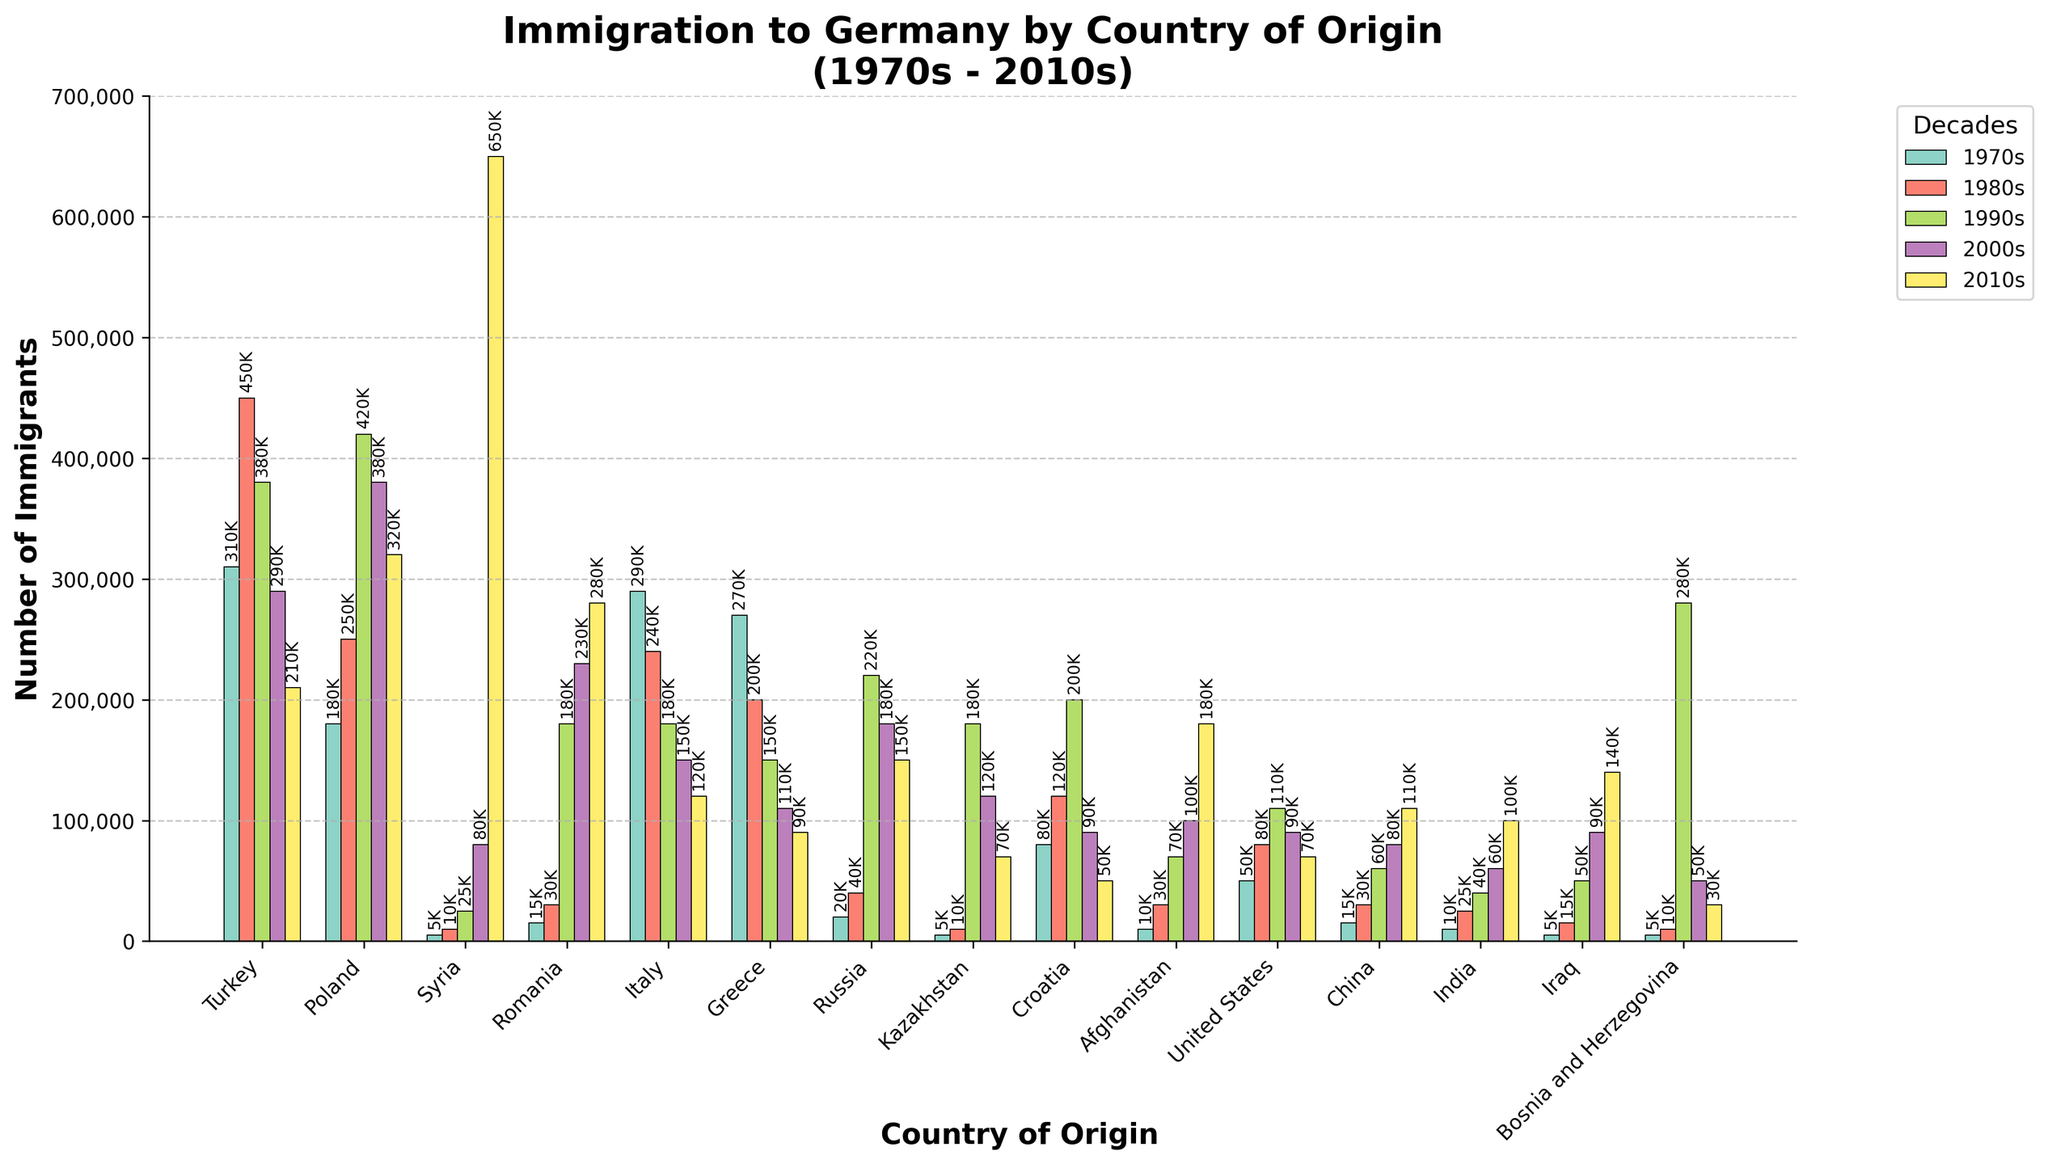Which country has the highest immigration to Germany in the 2010s? To determine the country with the highest immigration in the 2010s, look at the bar heights for the 2010s. The tallest bar corresponds to Syria.
Answer: Syria What is the total number of immigrants from Turkey to Germany over the five decades? Sum the number of immigrants from Turkey for each decade: 310,000 (1970s) + 450,000 (1980s) + 380,000 (1990s) + 290,000 (2000s) + 210,000 (2010s) = 1,640,000.
Answer: 1,640,000 Which decade had the highest overall immigration for Poland? Compare the height of the bars for Poland across all decades, noting that the highest number is in the 2010s: 320,000.
Answer: 2010s Compare immigration trends from Greece and Italy; which country saw a steadier decline over the decades? Comparing the height of the bars for Greece and Italy across the decades, both show a decline, but Greece shows a more consistent reduction from 270,000 to 90,000, whereas Italy fluctuates more but also reduces from 290,000 to 120,000.
Answer: Greece Estimate the difference in the number of immigrants to Germany from Syria between the 2000s and 2010s. Subtract the number of immigrants in the 2000s from those in the 2010s for Syria: 650,000 - 80,000 = 570,000.
Answer: 570,000 Which two countries had similar immigration numbers to Germany in the 2000s? Compare the bar heights for each country in the 2000s and notice that Turkey (290,000) and Poland (380,000) are quite close.
Answer: Turkey and Poland What color represents the 1980s decade in the bar chart? Refer to the color legend in the chart to identify which color corresponds to the 1980s. For example, it can be inferred from the color legend (which may be color-coded)
Answer: Color representing the 1980s in the legend Calculate the average number of immigrants from Romania across all five decades. Calculate the sum of immigrants from the chart data for Romania and divide by 5: (15,000 + 30,000 + 180,000 + 230,000 + 280,000) / 5 = 147,000.
Answer: 147,000 